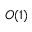<formula> <loc_0><loc_0><loc_500><loc_500>O ( 1 )</formula> 